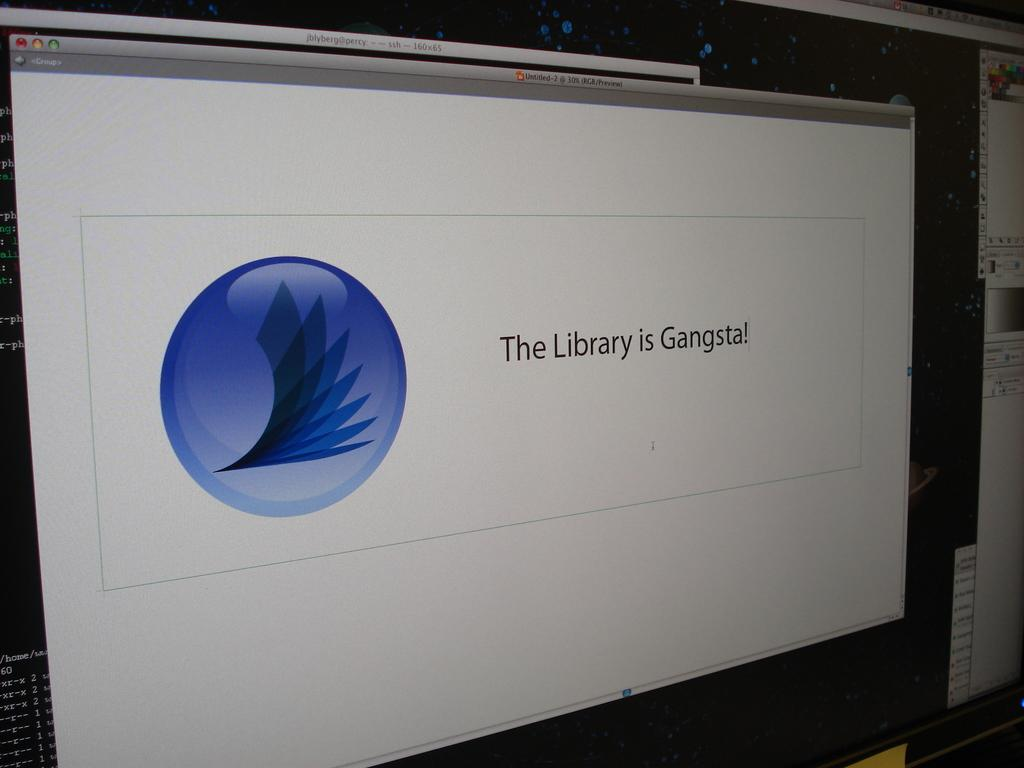Provide a one-sentence caption for the provided image. A application pulled up on the computer reading the library is gangsta. 